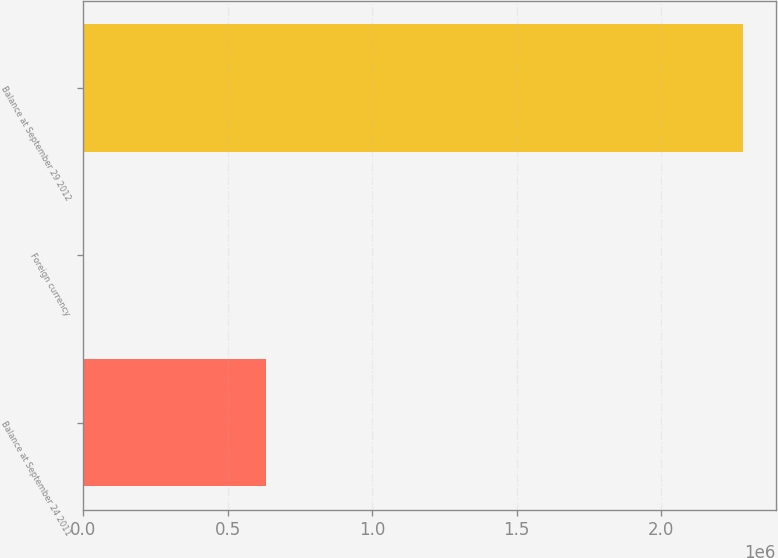Convert chart. <chart><loc_0><loc_0><loc_500><loc_500><bar_chart><fcel>Balance at September 24 2011<fcel>Foreign currency<fcel>Balance at September 29 2012<nl><fcel>633319<fcel>907<fcel>2.28345e+06<nl></chart> 